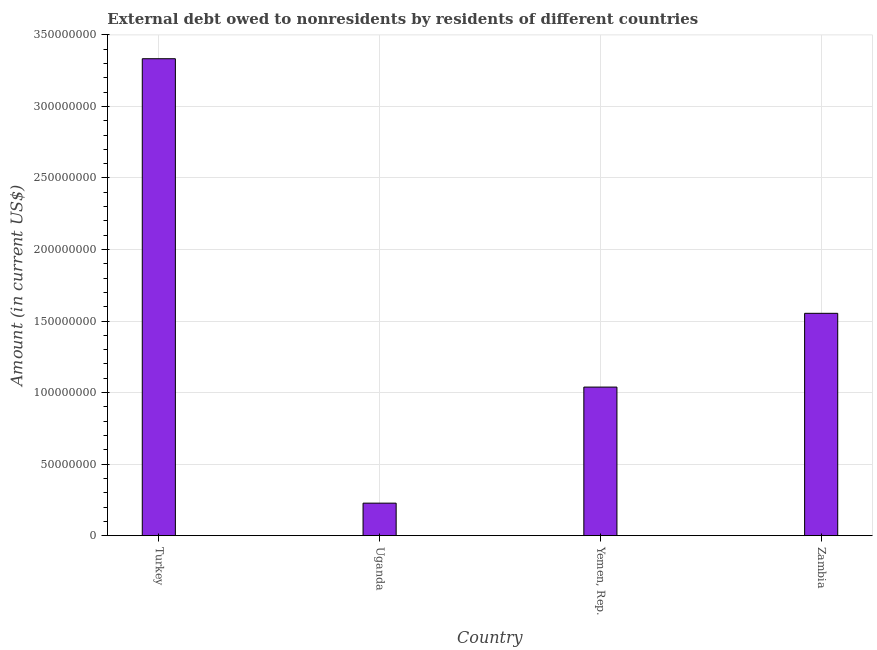Does the graph contain any zero values?
Offer a very short reply. No. Does the graph contain grids?
Your answer should be compact. Yes. What is the title of the graph?
Offer a very short reply. External debt owed to nonresidents by residents of different countries. What is the label or title of the Y-axis?
Ensure brevity in your answer.  Amount (in current US$). What is the debt in Turkey?
Provide a short and direct response. 3.33e+08. Across all countries, what is the maximum debt?
Your answer should be compact. 3.33e+08. Across all countries, what is the minimum debt?
Give a very brief answer. 2.27e+07. In which country was the debt maximum?
Your answer should be very brief. Turkey. In which country was the debt minimum?
Your answer should be very brief. Uganda. What is the sum of the debt?
Keep it short and to the point. 6.15e+08. What is the difference between the debt in Uganda and Zambia?
Your answer should be compact. -1.33e+08. What is the average debt per country?
Make the answer very short. 1.54e+08. What is the median debt?
Give a very brief answer. 1.30e+08. What is the ratio of the debt in Uganda to that in Yemen, Rep.?
Offer a terse response. 0.22. Is the debt in Uganda less than that in Yemen, Rep.?
Your response must be concise. Yes. What is the difference between the highest and the second highest debt?
Provide a short and direct response. 1.78e+08. Is the sum of the debt in Turkey and Zambia greater than the maximum debt across all countries?
Keep it short and to the point. Yes. What is the difference between the highest and the lowest debt?
Offer a very short reply. 3.11e+08. Are all the bars in the graph horizontal?
Keep it short and to the point. No. How many countries are there in the graph?
Your answer should be very brief. 4. What is the difference between two consecutive major ticks on the Y-axis?
Offer a very short reply. 5.00e+07. What is the Amount (in current US$) of Turkey?
Ensure brevity in your answer.  3.33e+08. What is the Amount (in current US$) in Uganda?
Your answer should be very brief. 2.27e+07. What is the Amount (in current US$) in Yemen, Rep.?
Provide a succinct answer. 1.04e+08. What is the Amount (in current US$) in Zambia?
Offer a terse response. 1.55e+08. What is the difference between the Amount (in current US$) in Turkey and Uganda?
Your answer should be compact. 3.11e+08. What is the difference between the Amount (in current US$) in Turkey and Yemen, Rep.?
Give a very brief answer. 2.30e+08. What is the difference between the Amount (in current US$) in Turkey and Zambia?
Offer a terse response. 1.78e+08. What is the difference between the Amount (in current US$) in Uganda and Yemen, Rep.?
Your response must be concise. -8.11e+07. What is the difference between the Amount (in current US$) in Uganda and Zambia?
Your response must be concise. -1.33e+08. What is the difference between the Amount (in current US$) in Yemen, Rep. and Zambia?
Ensure brevity in your answer.  -5.16e+07. What is the ratio of the Amount (in current US$) in Turkey to that in Uganda?
Your response must be concise. 14.66. What is the ratio of the Amount (in current US$) in Turkey to that in Yemen, Rep.?
Offer a terse response. 3.21. What is the ratio of the Amount (in current US$) in Turkey to that in Zambia?
Your response must be concise. 2.15. What is the ratio of the Amount (in current US$) in Uganda to that in Yemen, Rep.?
Your answer should be compact. 0.22. What is the ratio of the Amount (in current US$) in Uganda to that in Zambia?
Offer a very short reply. 0.15. What is the ratio of the Amount (in current US$) in Yemen, Rep. to that in Zambia?
Your answer should be compact. 0.67. 